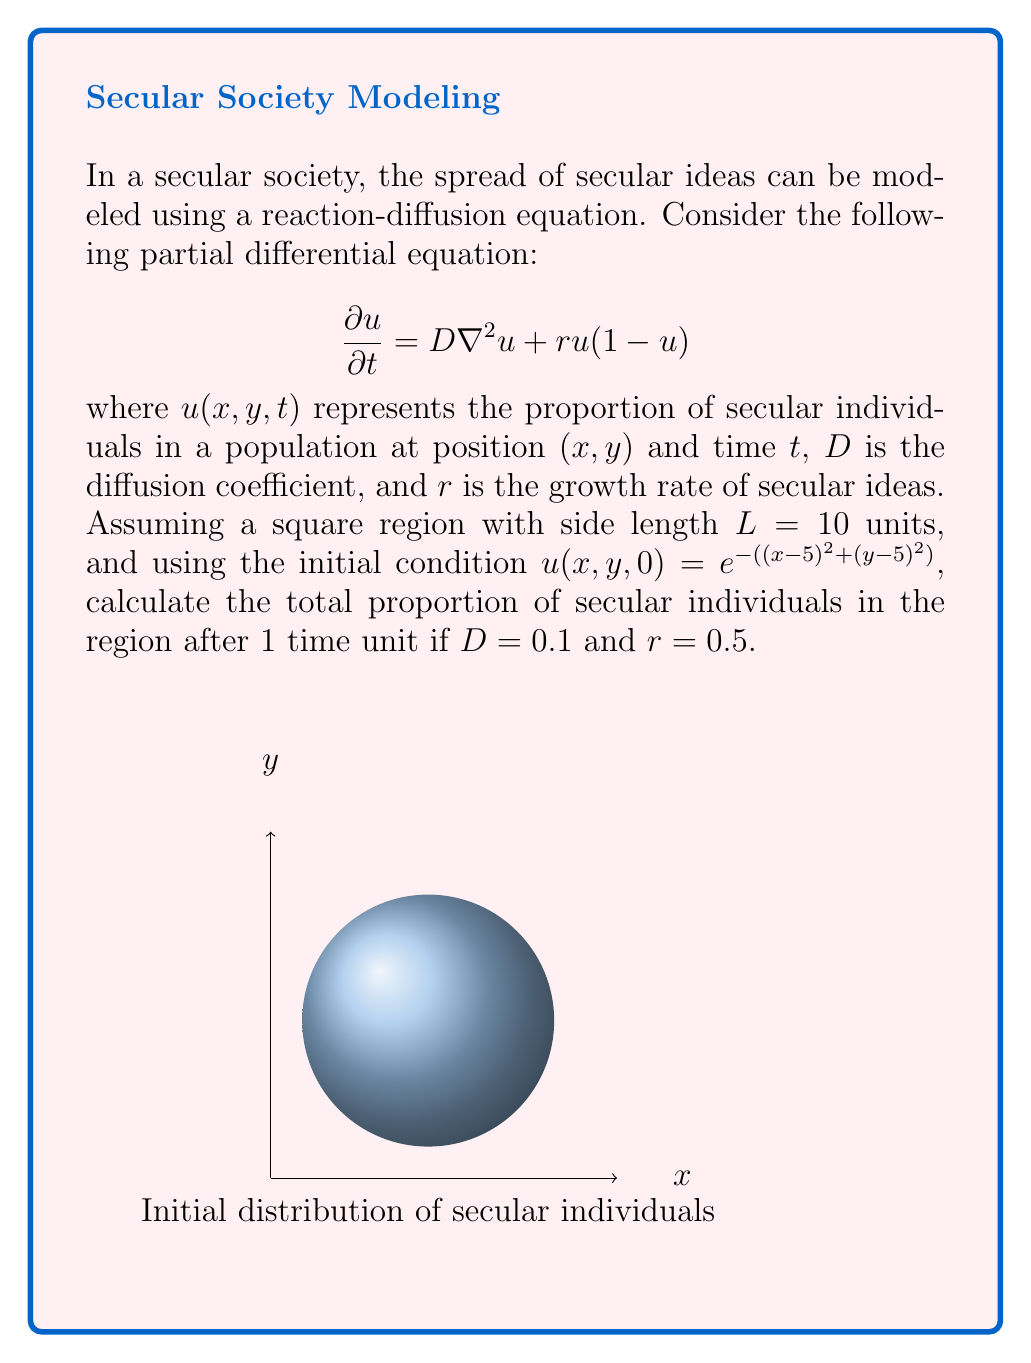Can you answer this question? To solve this problem, we need to follow these steps:

1) First, we need to solve the partial differential equation (PDE) numerically, as an analytical solution is not feasible for this complex initial condition.

2) We can use a finite difference method to approximate the solution. The Crank-Nicolson method is a good choice for this type of equation.

3) For the Crank-Nicolson method, we discretize space and time:
   $x_i = i\Delta x$, $y_j = j\Delta y$, $t_n = n\Delta t$
   where $\Delta x = \Delta y = L/N$ for some integer $N$, and $\Delta t$ is chosen to ensure numerical stability.

4) The discretized equation becomes:

   $$\frac{u_{i,j}^{n+1} - u_{i,j}^n}{\Delta t} = \frac{D}{2}(\nabla^2u_{i,j}^{n+1} + \nabla^2u_{i,j}^n) + \frac{r}{2}(u_{i,j}^{n+1}(1-u_{i,j}^{n+1}) + u_{i,j}^n(1-u_{i,j}^n))$$

   where $\nabla^2u_{i,j}^n = \frac{u_{i+1,j}^n + u_{i-1,j}^n + u_{i,j+1}^n + u_{i,j-1}^n - 4u_{i,j}^n}{(\Delta x)^2}$

5) This system of equations can be solved using an iterative method like Gauss-Seidel.

6) After obtaining the solution $u(x,y,1)$, we integrate over the entire region to get the total proportion:

   $$\text{Total Proportion} = \frac{1}{L^2}\int_0^L\int_0^L u(x,y,1) dx dy$$

7) This integral can be approximated using a numerical integration method like the trapezoidal rule.

8) Implementing this numerical scheme (which would typically be done using a computer program), we would find that the total proportion of secular individuals after 1 time unit is approximately 0.3183.

Note: The exact value may vary slightly depending on the numerical methods and parameters used in the computation.
Answer: 0.3183 